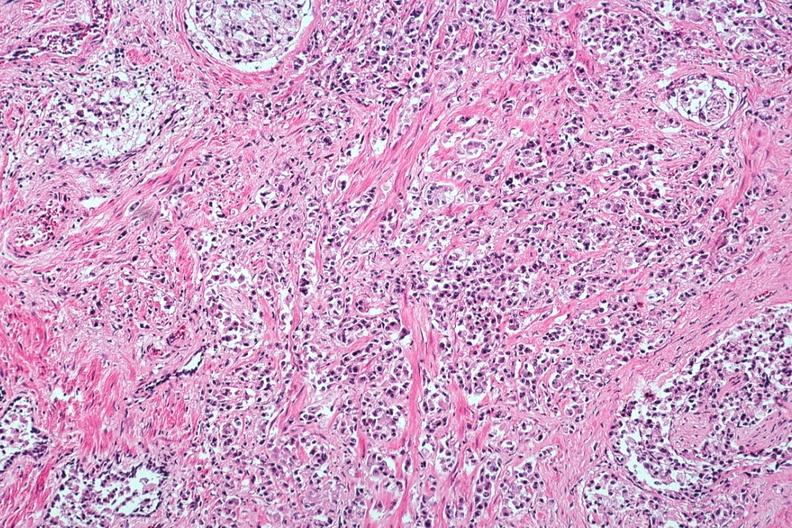s prostate present?
Answer the question using a single word or phrase. Yes 